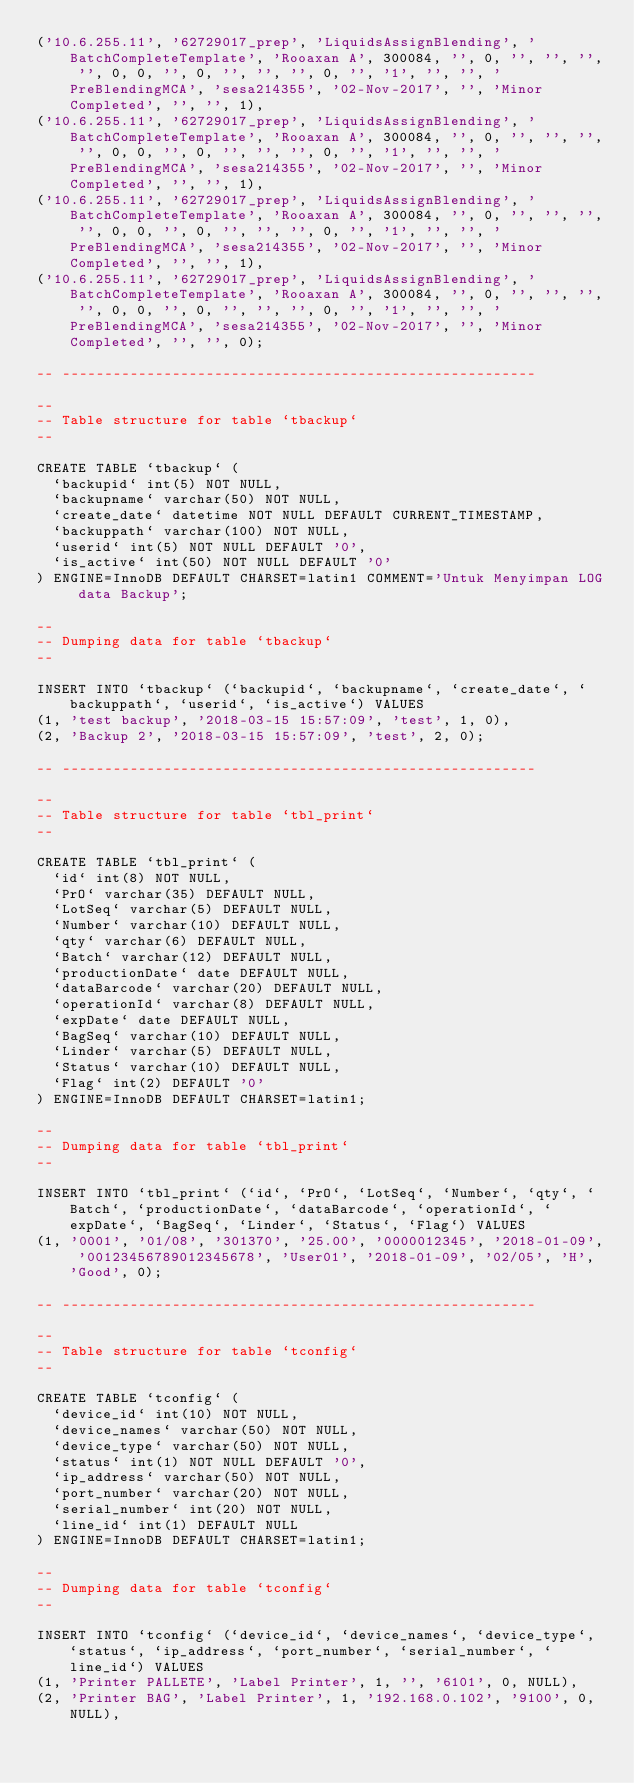<code> <loc_0><loc_0><loc_500><loc_500><_SQL_>('10.6.255.11', '62729017_prep', 'LiquidsAssignBlending', 'BatchCompleteTemplate', 'Rooaxan A', 300084, '', 0, '', '', '', '', 0, 0, '', 0, '', '', '', 0, '', '1', '', '', 'PreBlendingMCA', 'sesa214355', '02-Nov-2017', '', 'Minor Completed', '', '', 1),
('10.6.255.11', '62729017_prep', 'LiquidsAssignBlending', 'BatchCompleteTemplate', 'Rooaxan A', 300084, '', 0, '', '', '', '', 0, 0, '', 0, '', '', '', 0, '', '1', '', '', 'PreBlendingMCA', 'sesa214355', '02-Nov-2017', '', 'Minor Completed', '', '', 1),
('10.6.255.11', '62729017_prep', 'LiquidsAssignBlending', 'BatchCompleteTemplate', 'Rooaxan A', 300084, '', 0, '', '', '', '', 0, 0, '', 0, '', '', '', 0, '', '1', '', '', 'PreBlendingMCA', 'sesa214355', '02-Nov-2017', '', 'Minor Completed', '', '', 1),
('10.6.255.11', '62729017_prep', 'LiquidsAssignBlending', 'BatchCompleteTemplate', 'Rooaxan A', 300084, '', 0, '', '', '', '', 0, 0, '', 0, '', '', '', 0, '', '1', '', '', 'PreBlendingMCA', 'sesa214355', '02-Nov-2017', '', 'Minor Completed', '', '', 0);

-- --------------------------------------------------------

--
-- Table structure for table `tbackup`
--

CREATE TABLE `tbackup` (
  `backupid` int(5) NOT NULL,
  `backupname` varchar(50) NOT NULL,
  `create_date` datetime NOT NULL DEFAULT CURRENT_TIMESTAMP,
  `backuppath` varchar(100) NOT NULL,
  `userid` int(5) NOT NULL DEFAULT '0',
  `is_active` int(50) NOT NULL DEFAULT '0'
) ENGINE=InnoDB DEFAULT CHARSET=latin1 COMMENT='Untuk Menyimpan LOG data Backup';

--
-- Dumping data for table `tbackup`
--

INSERT INTO `tbackup` (`backupid`, `backupname`, `create_date`, `backuppath`, `userid`, `is_active`) VALUES
(1, 'test backup', '2018-03-15 15:57:09', 'test', 1, 0),
(2, 'Backup 2', '2018-03-15 15:57:09', 'test', 2, 0);

-- --------------------------------------------------------

--
-- Table structure for table `tbl_print`
--

CREATE TABLE `tbl_print` (
  `id` int(8) NOT NULL,
  `PrO` varchar(35) DEFAULT NULL,
  `LotSeq` varchar(5) DEFAULT NULL,
  `Number` varchar(10) DEFAULT NULL,
  `qty` varchar(6) DEFAULT NULL,
  `Batch` varchar(12) DEFAULT NULL,
  `productionDate` date DEFAULT NULL,
  `dataBarcode` varchar(20) DEFAULT NULL,
  `operationId` varchar(8) DEFAULT NULL,
  `expDate` date DEFAULT NULL,
  `BagSeq` varchar(10) DEFAULT NULL,
  `Linder` varchar(5) DEFAULT NULL,
  `Status` varchar(10) DEFAULT NULL,
  `Flag` int(2) DEFAULT '0'
) ENGINE=InnoDB DEFAULT CHARSET=latin1;

--
-- Dumping data for table `tbl_print`
--

INSERT INTO `tbl_print` (`id`, `PrO`, `LotSeq`, `Number`, `qty`, `Batch`, `productionDate`, `dataBarcode`, `operationId`, `expDate`, `BagSeq`, `Linder`, `Status`, `Flag`) VALUES
(1, '0001', '01/08', '301370', '25.00', '0000012345', '2018-01-09', '00123456789012345678', 'User01', '2018-01-09', '02/05', 'H', 'Good', 0);

-- --------------------------------------------------------

--
-- Table structure for table `tconfig`
--

CREATE TABLE `tconfig` (
  `device_id` int(10) NOT NULL,
  `device_names` varchar(50) NOT NULL,
  `device_type` varchar(50) NOT NULL,
  `status` int(1) NOT NULL DEFAULT '0',
  `ip_address` varchar(50) NOT NULL,
  `port_number` varchar(20) NOT NULL,
  `serial_number` int(20) NOT NULL,
  `line_id` int(1) DEFAULT NULL
) ENGINE=InnoDB DEFAULT CHARSET=latin1;

--
-- Dumping data for table `tconfig`
--

INSERT INTO `tconfig` (`device_id`, `device_names`, `device_type`, `status`, `ip_address`, `port_number`, `serial_number`, `line_id`) VALUES
(1, 'Printer PALLETE', 'Label Printer', 1, '', '6101', 0, NULL),
(2, 'Printer BAG', 'Label Printer', 1, '192.168.0.102', '9100', 0, NULL),</code> 